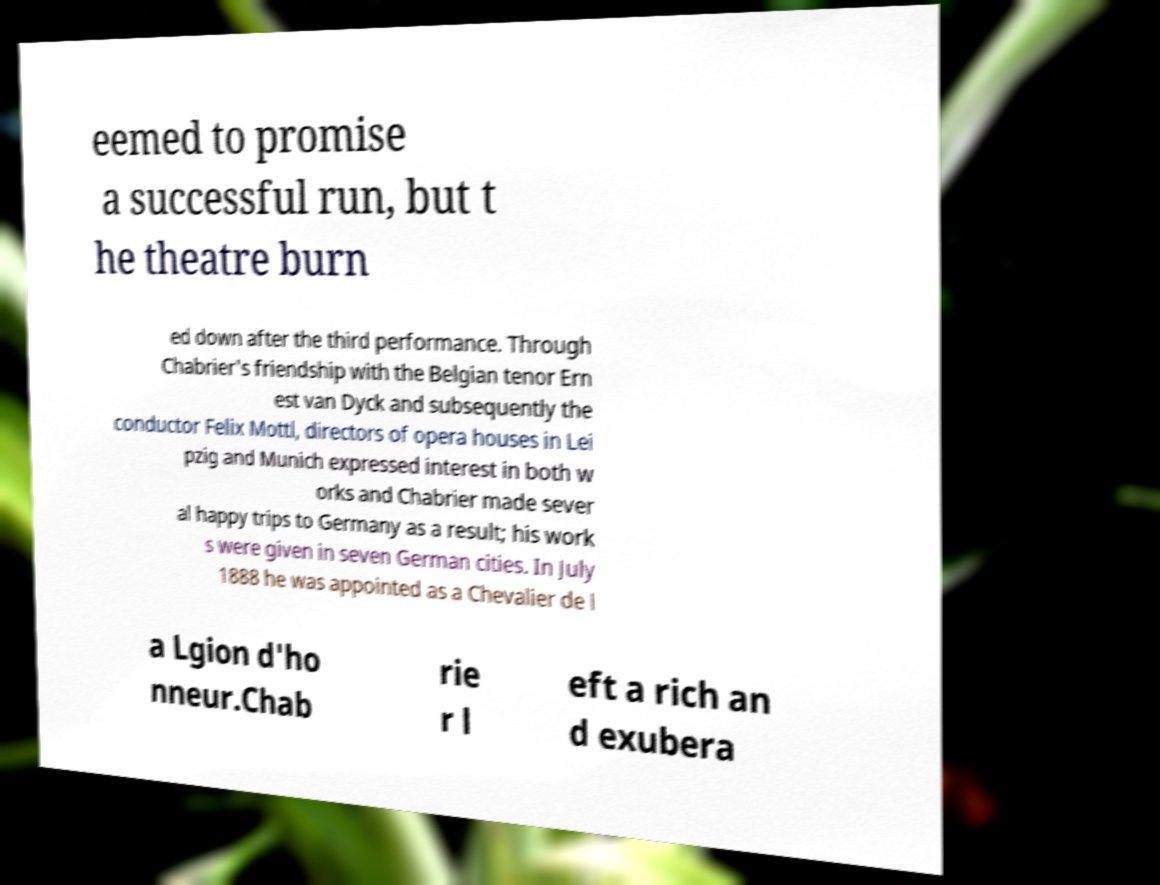Can you read and provide the text displayed in the image?This photo seems to have some interesting text. Can you extract and type it out for me? eemed to promise a successful run, but t he theatre burn ed down after the third performance. Through Chabrier's friendship with the Belgian tenor Ern est van Dyck and subsequently the conductor Felix Mottl, directors of opera houses in Lei pzig and Munich expressed interest in both w orks and Chabrier made sever al happy trips to Germany as a result; his work s were given in seven German cities. In July 1888 he was appointed as a Chevalier de l a Lgion d'ho nneur.Chab rie r l eft a rich an d exubera 